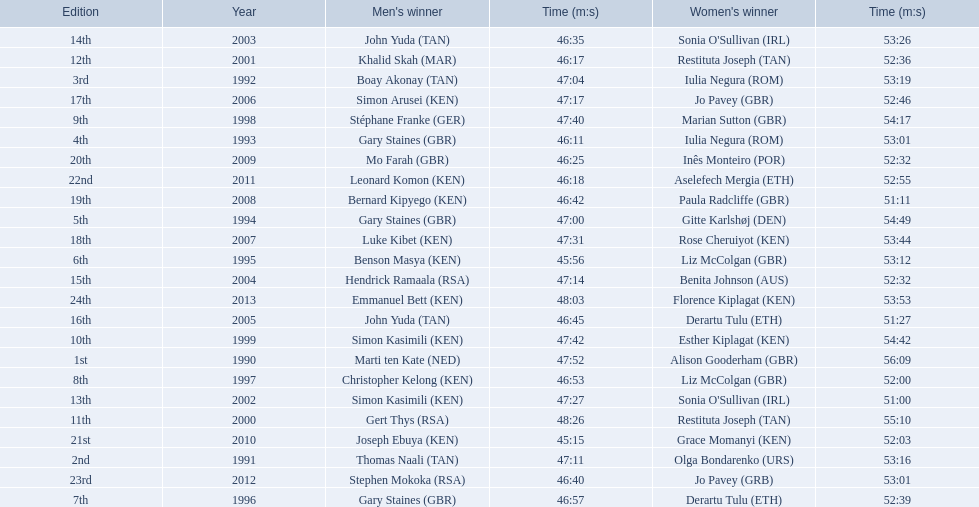Which runners are from kenya? (ken) Benson Masya (KEN), Christopher Kelong (KEN), Simon Kasimili (KEN), Simon Kasimili (KEN), Simon Arusei (KEN), Luke Kibet (KEN), Bernard Kipyego (KEN), Joseph Ebuya (KEN), Leonard Komon (KEN), Emmanuel Bett (KEN). Of these, which times are under 46 minutes? Benson Masya (KEN), Joseph Ebuya (KEN). Which of these runners had the faster time? Joseph Ebuya (KEN). 